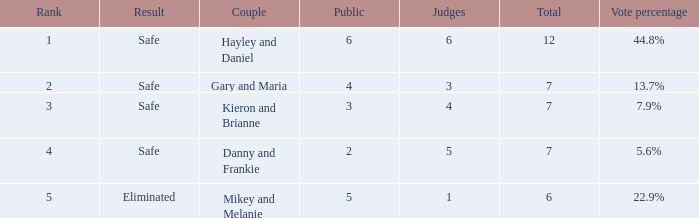What was the total number when the vote percentage was 44.8%? 1.0. 